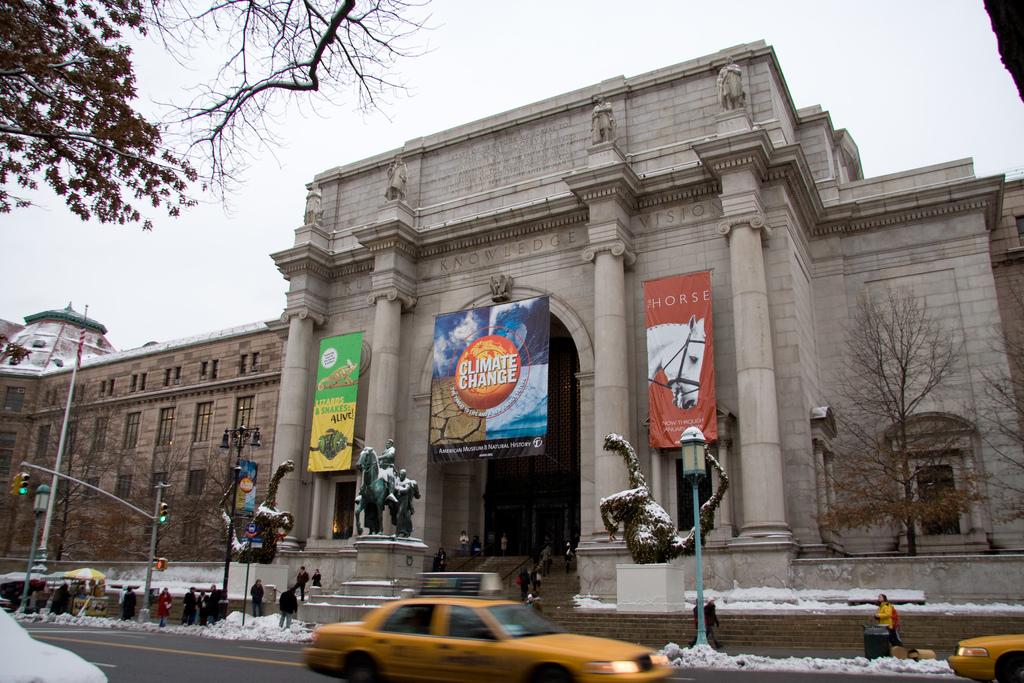What kind of change?
Provide a succinct answer. Climate. 